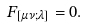<formula> <loc_0><loc_0><loc_500><loc_500>F _ { [ \mu \nu ; \lambda ] } = 0 .</formula> 